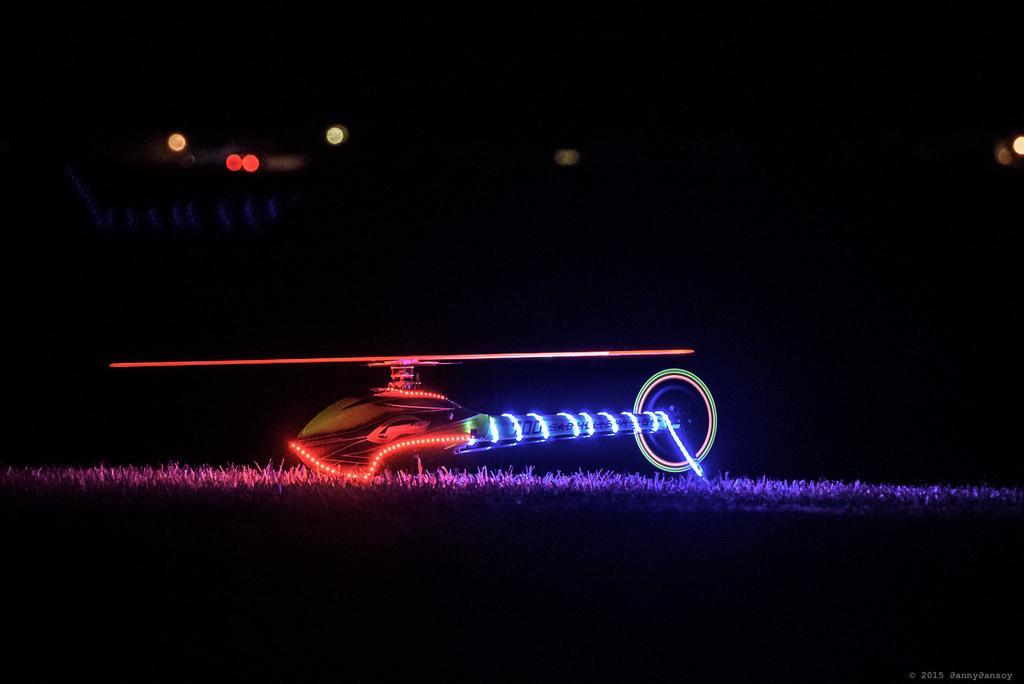In one or two sentences, can you explain what this image depicts? In this picture we can see a helicopter on the ground, here we can see grass, lights and in the background we can see it is dark. 